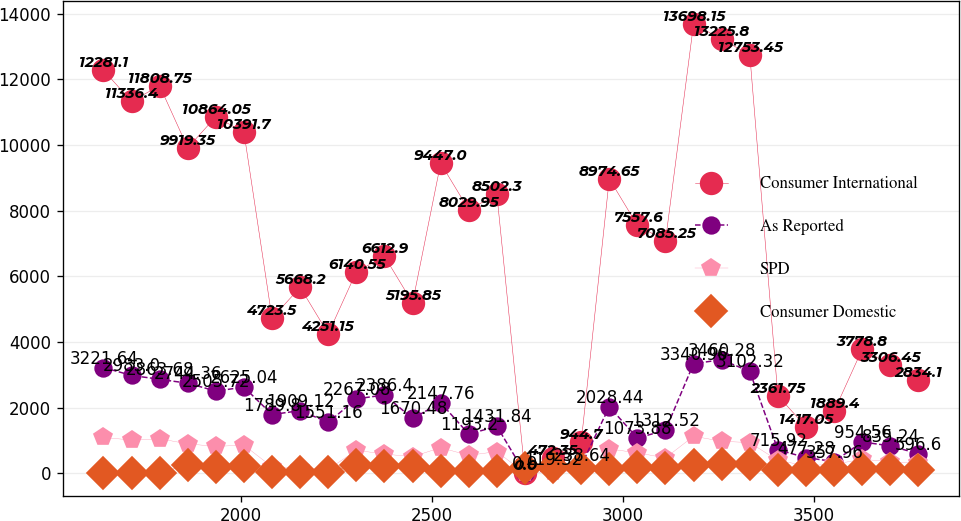Convert chart. <chart><loc_0><loc_0><loc_500><loc_500><line_chart><ecel><fcel>Consumer International<fcel>As Reported<fcel>SPD<fcel>Consumer Domestic<nl><fcel>1640.3<fcel>12281.1<fcel>3221.64<fcel>1091.44<fcel>0<nl><fcel>1713.9<fcel>11336.4<fcel>2983<fcel>1013.48<fcel>9.56<nl><fcel>1787.5<fcel>11808.8<fcel>2863.68<fcel>1052.46<fcel>19.12<nl><fcel>1861.1<fcel>9919.35<fcel>2744.36<fcel>896.54<fcel>248.56<nl><fcel>1934.7<fcel>10864<fcel>2505.72<fcel>818.58<fcel>200.76<nl><fcel>2008.3<fcel>10391.7<fcel>2625.04<fcel>857.56<fcel>229.44<nl><fcel>2081.9<fcel>4723.5<fcel>1789.8<fcel>194.9<fcel>28.68<nl><fcel>2155.5<fcel>5668.2<fcel>1909.12<fcel>155.92<fcel>38.24<nl><fcel>2229.1<fcel>4251.15<fcel>1551.16<fcel>116.94<fcel>47.8<nl><fcel>2302.7<fcel>6140.55<fcel>2267.08<fcel>701.64<fcel>239<nl><fcel>2376.3<fcel>6612.9<fcel>2386.4<fcel>584.7<fcel>210.32<nl><fcel>2449.9<fcel>5195.85<fcel>1670.48<fcel>506.74<fcel>219.88<nl><fcel>2523.5<fcel>9447<fcel>2147.76<fcel>779.6<fcel>57.36<nl><fcel>2597.1<fcel>8029.95<fcel>1193.2<fcel>545.72<fcel>66.92<nl><fcel>2670.7<fcel>8502.3<fcel>1431.84<fcel>662.66<fcel>76.48<nl><fcel>2744.3<fcel>0<fcel>0<fcel>0<fcel>152.96<nl><fcel>2817.9<fcel>472.35<fcel>119.32<fcel>38.98<fcel>191.2<nl><fcel>2891.5<fcel>944.7<fcel>238.64<fcel>77.96<fcel>172.08<nl><fcel>2965.1<fcel>8974.65<fcel>2028.44<fcel>740.62<fcel>143.4<nl><fcel>3038.7<fcel>7557.6<fcel>1073.88<fcel>623.68<fcel>181.64<nl><fcel>3112.3<fcel>7085.25<fcel>1312.52<fcel>467.76<fcel>162.52<nl><fcel>3185.9<fcel>13698.1<fcel>3340.96<fcel>1130.42<fcel>258.12<nl><fcel>3259.5<fcel>13225.8<fcel>3460.28<fcel>974.5<fcel>277.24<nl><fcel>3333.1<fcel>12753.5<fcel>3102.32<fcel>935.52<fcel>267.68<nl><fcel>3406.7<fcel>2361.75<fcel>715.92<fcel>389.8<fcel>86.04<nl><fcel>3480.3<fcel>1417.05<fcel>477.28<fcel>233.88<fcel>95.6<nl><fcel>3553.9<fcel>1889.4<fcel>357.96<fcel>272.86<fcel>105.16<nl><fcel>3627.5<fcel>3778.8<fcel>954.56<fcel>428.78<fcel>133.84<nl><fcel>3701.1<fcel>3306.45<fcel>835.24<fcel>350.82<fcel>124.28<nl><fcel>3774.7<fcel>2834.1<fcel>596.6<fcel>311.84<fcel>114.72<nl></chart> 